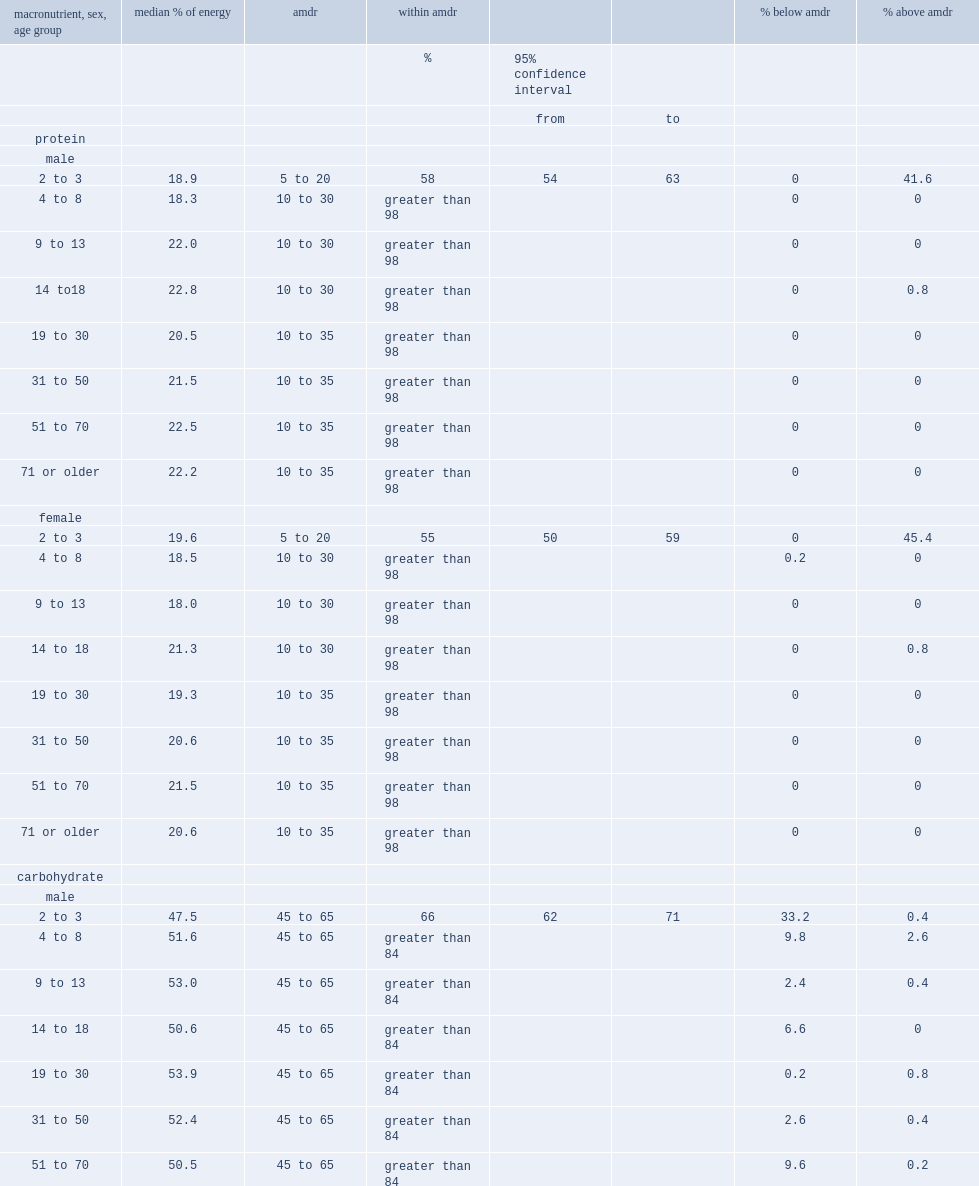How many of the diets for male 2- to 3-yeaer-olds exceeded the amdr for protein? 41.6. How many of the diets for male 2- to 3-yeaer-olds exceeded the amdr for protein? 45.4. How many of the diets for male 2- to 3-yeaer-olds exceeded the amdr for carbohydrates? 33.2. How many of the diets for female 2- to 3-yeaer-olds exceeded the amdr for carbohydrates? 39.6. 